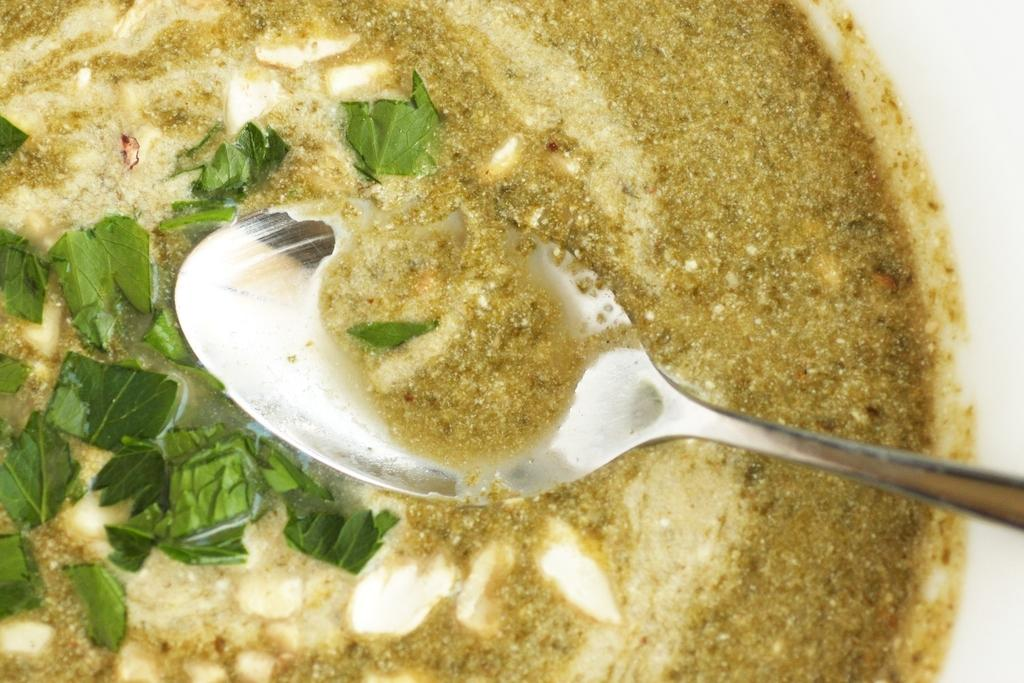What is in the bowl that is visible in the image? There is food in a bowl in the image. What utensil is present in the image? There is a spoon in the image. What type of writing can be seen on the list in the image? There is no list present in the image, so it is not possible to determine what type of writing might be on it. 